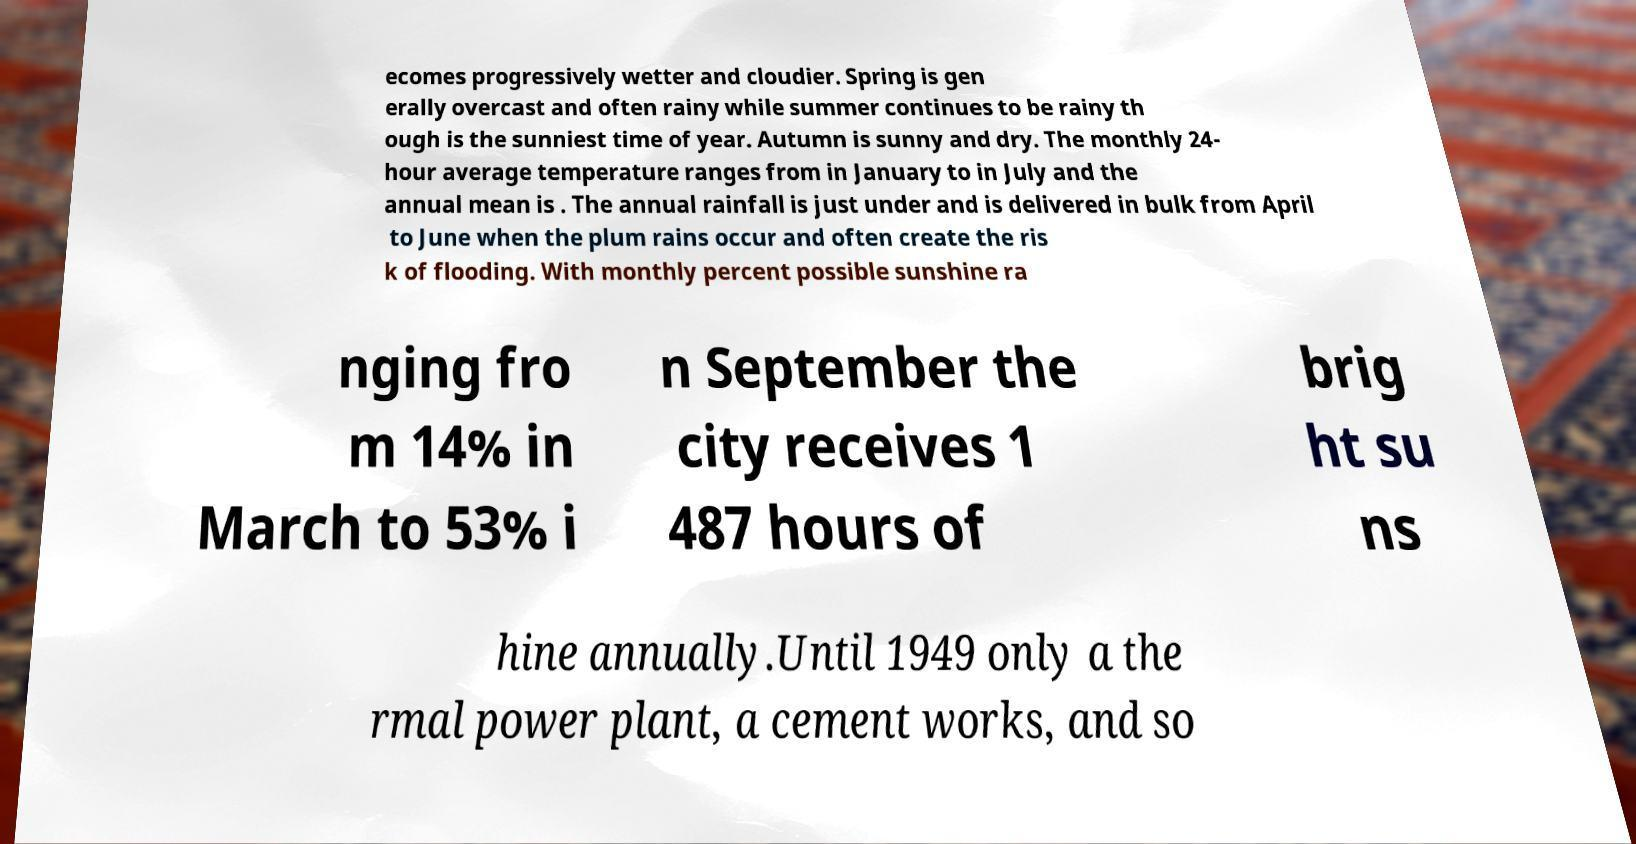What messages or text are displayed in this image? I need them in a readable, typed format. ecomes progressively wetter and cloudier. Spring is gen erally overcast and often rainy while summer continues to be rainy th ough is the sunniest time of year. Autumn is sunny and dry. The monthly 24- hour average temperature ranges from in January to in July and the annual mean is . The annual rainfall is just under and is delivered in bulk from April to June when the plum rains occur and often create the ris k of flooding. With monthly percent possible sunshine ra nging fro m 14% in March to 53% i n September the city receives 1 487 hours of brig ht su ns hine annually.Until 1949 only a the rmal power plant, a cement works, and so 